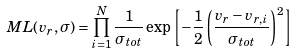Convert formula to latex. <formula><loc_0><loc_0><loc_500><loc_500>M L ( v _ { r } , \sigma ) = \prod _ { i = 1 } ^ { N } \frac { 1 } { \sigma _ { t o t } } \exp \left [ - \frac { 1 } { 2 } \left ( \frac { v _ { r } - v _ { r , i } } { \sigma _ { t o t } } \right ) ^ { 2 } \right ]</formula> 